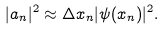Convert formula to latex. <formula><loc_0><loc_0><loc_500><loc_500>| a _ { n } | ^ { 2 } \approx \Delta x _ { n } | \psi ( x _ { n } ) | ^ { 2 } .</formula> 